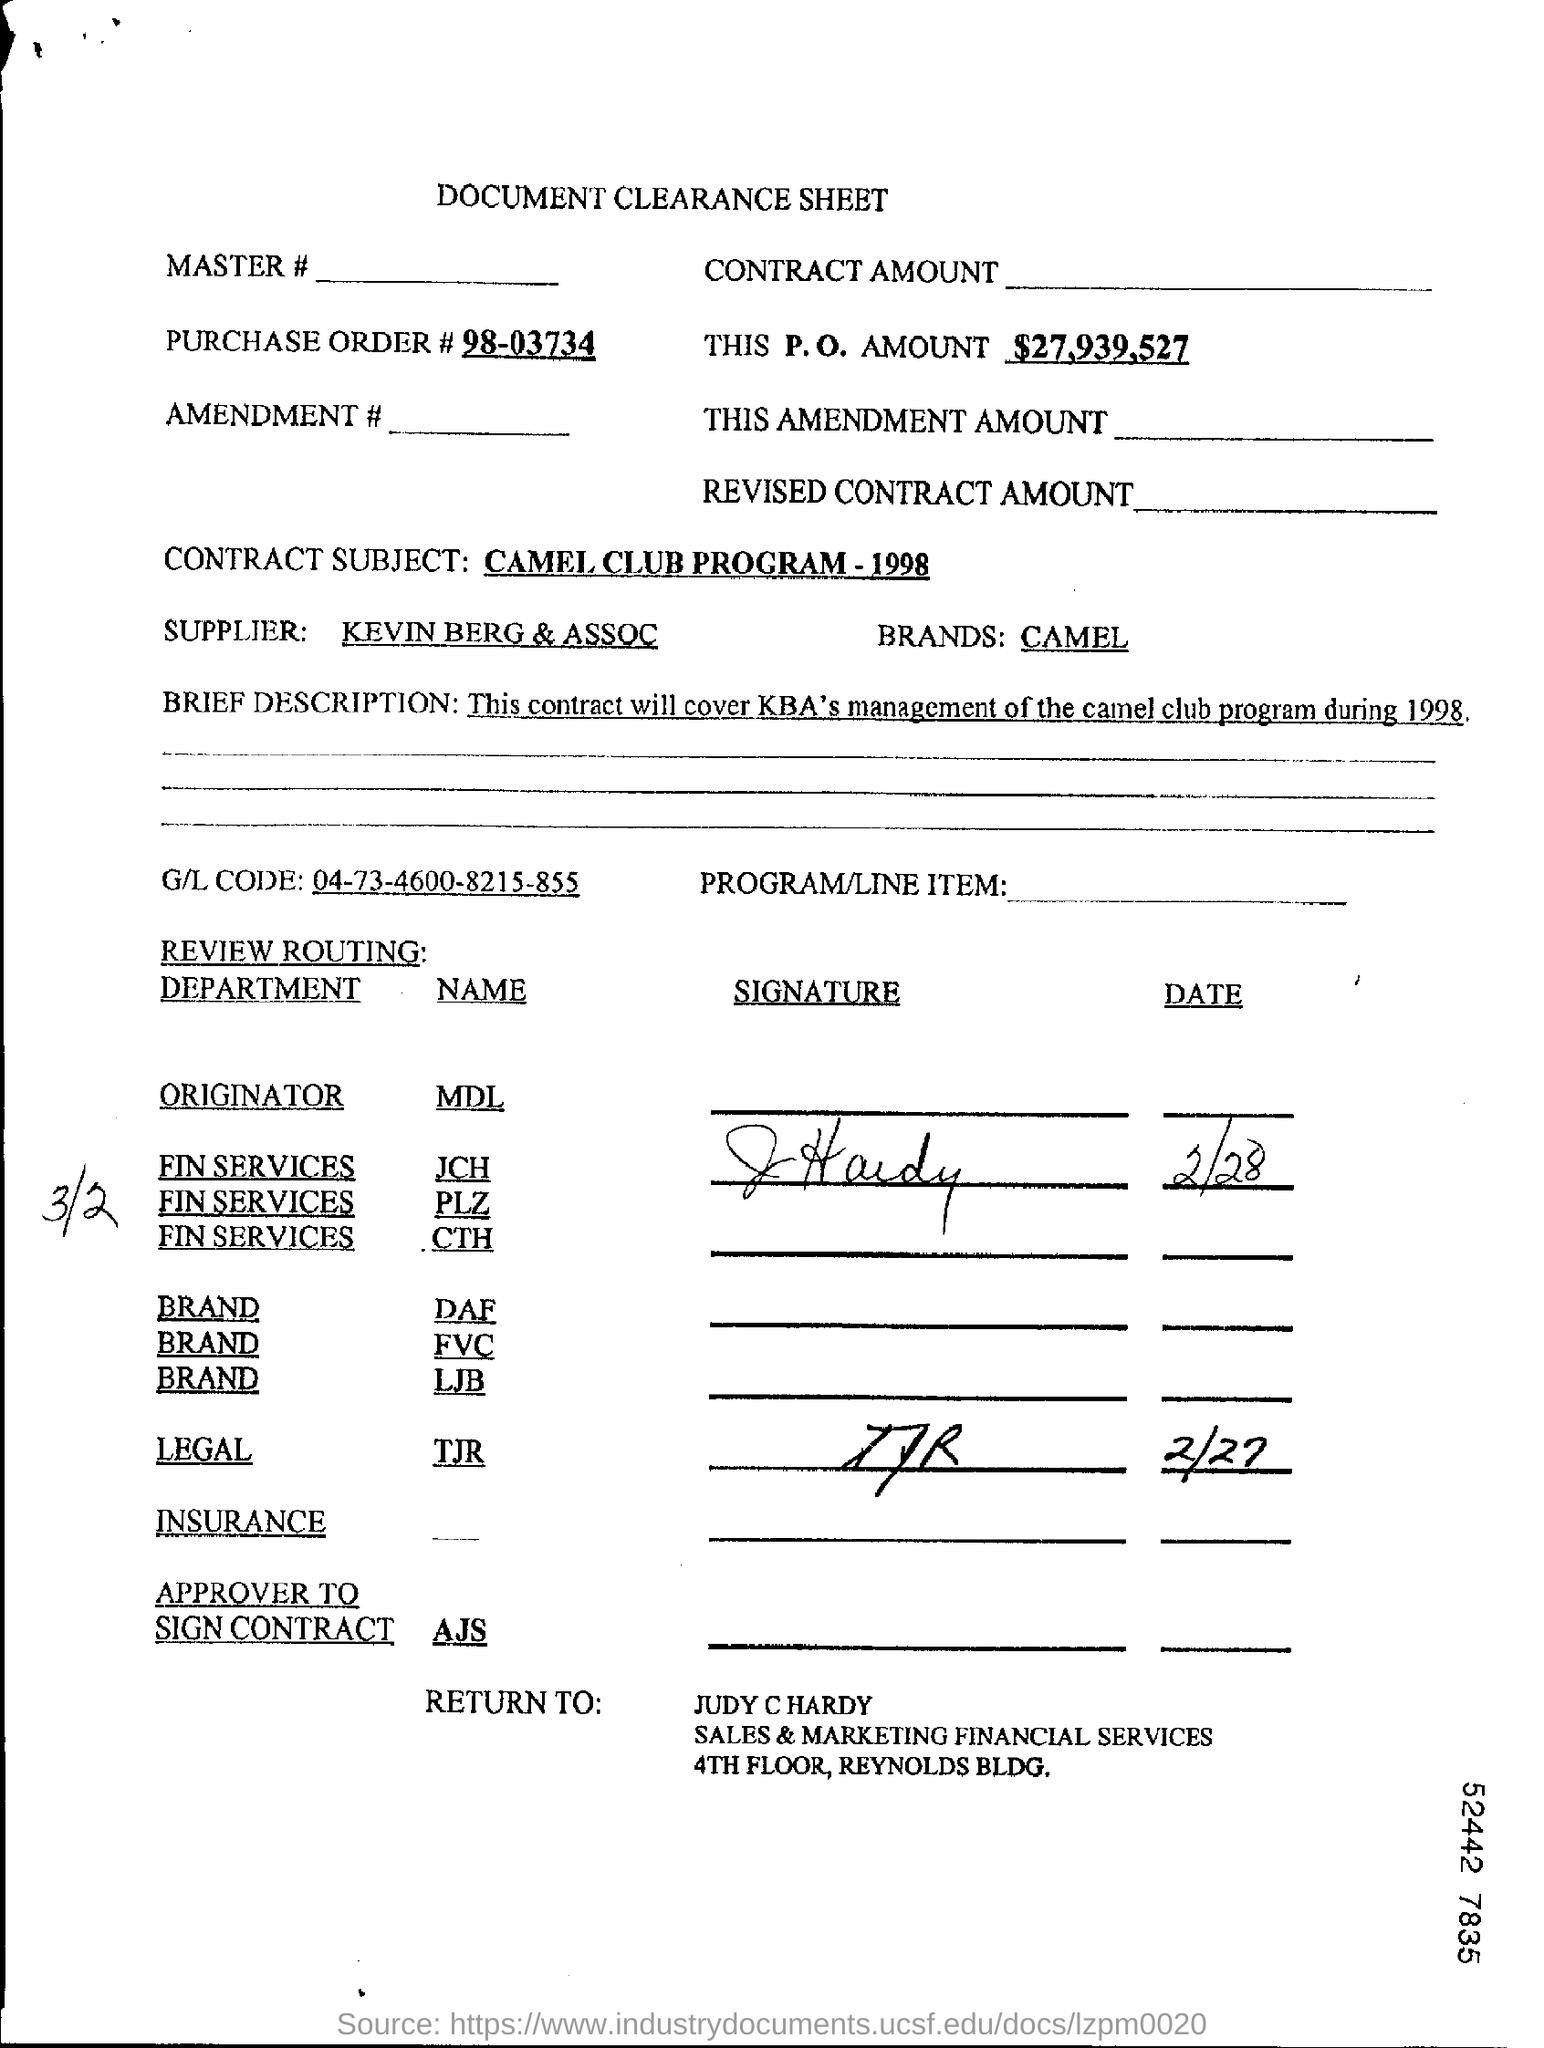What is the purchase order number?
Your answer should be very brief. 98-03734. What is this P.O. Amount?
Offer a very short reply. $27,939,527. What is the contract subject?
Your answer should be very brief. CAMEL CLUB PROGRAM - 1998. Who is the supplier?
Your answer should be compact. KEVIN BERG & ASSOC. What is the G/L Account Code mentioned?
Your answer should be very brief. 04-73-4600-8215-855. To whom should the form be returned?
Your answer should be compact. Judy c hardy. 